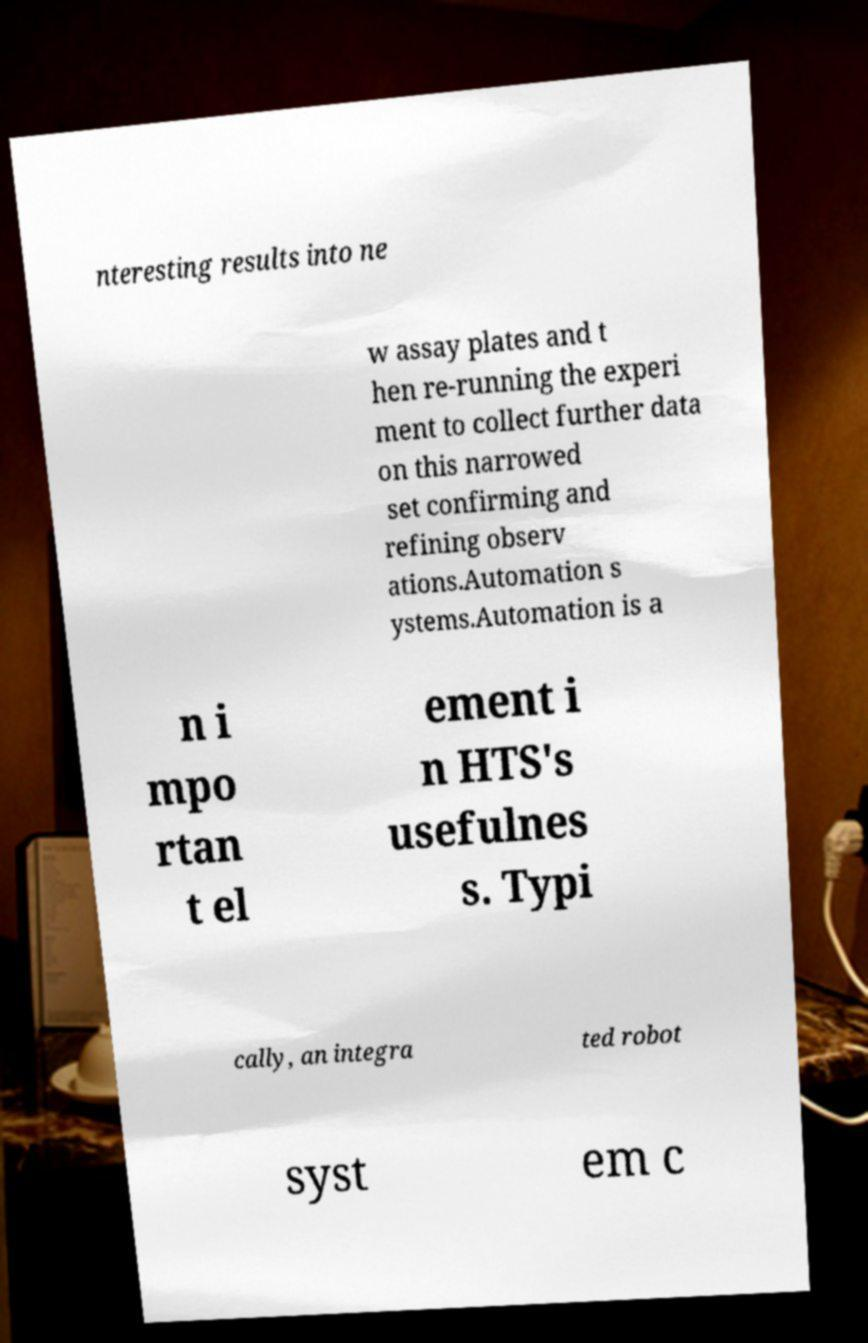What messages or text are displayed in this image? I need them in a readable, typed format. nteresting results into ne w assay plates and t hen re-running the experi ment to collect further data on this narrowed set confirming and refining observ ations.Automation s ystems.Automation is a n i mpo rtan t el ement i n HTS's usefulnes s. Typi cally, an integra ted robot syst em c 